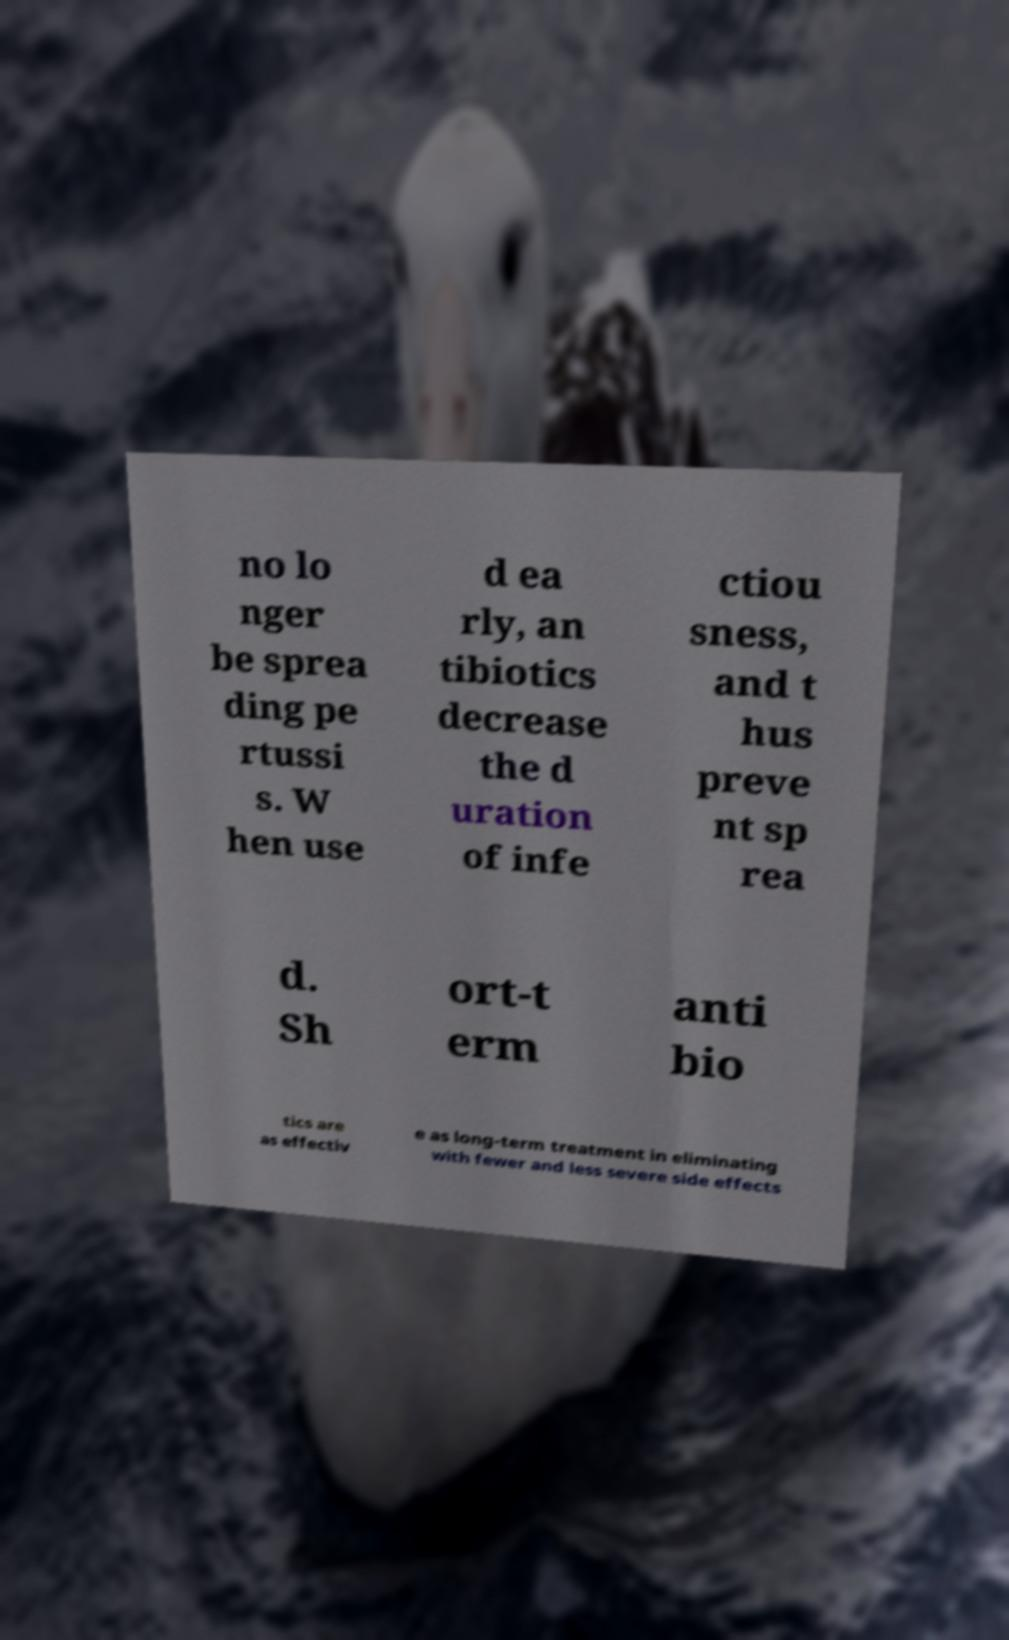Can you accurately transcribe the text from the provided image for me? no lo nger be sprea ding pe rtussi s. W hen use d ea rly, an tibiotics decrease the d uration of infe ctiou sness, and t hus preve nt sp rea d. Sh ort-t erm anti bio tics are as effectiv e as long-term treatment in eliminating with fewer and less severe side effects 